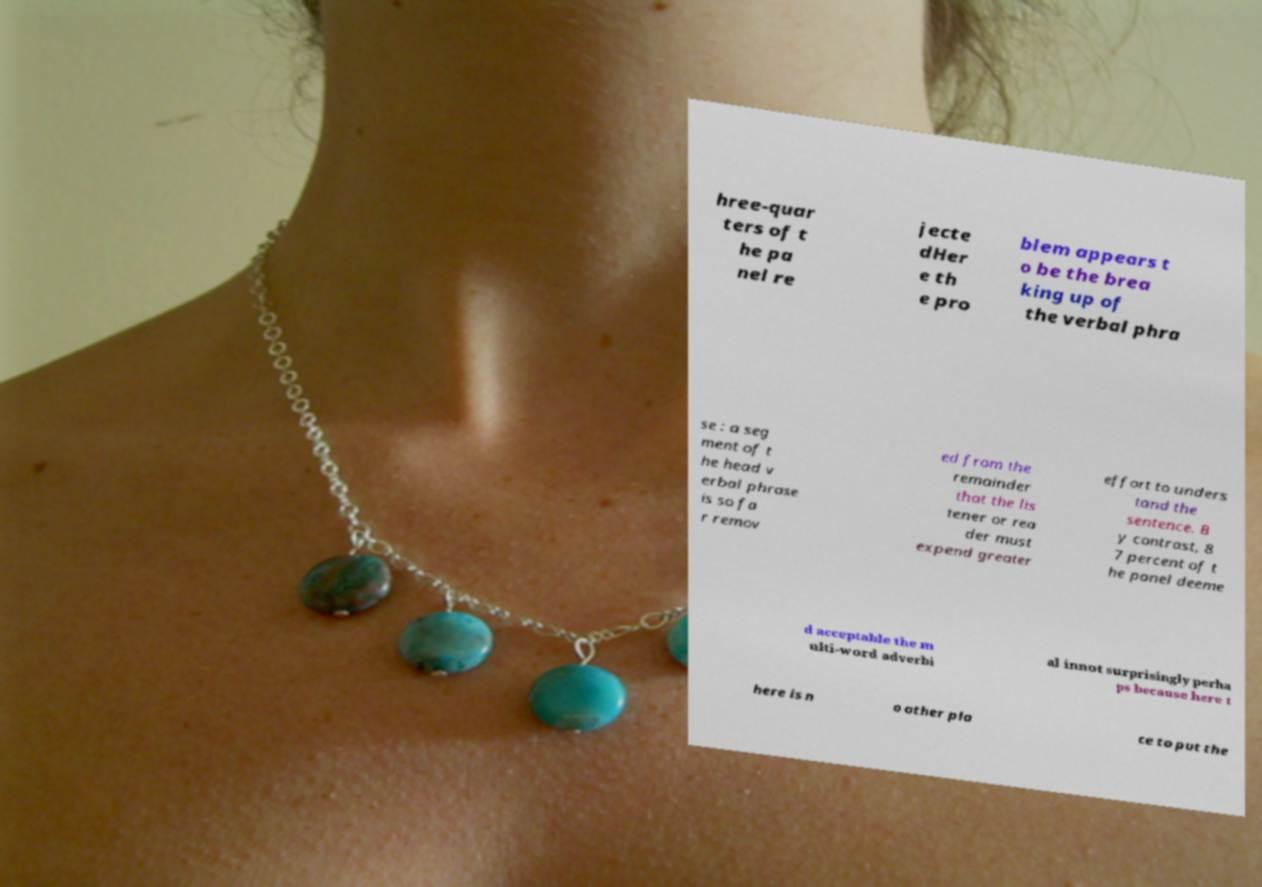I need the written content from this picture converted into text. Can you do that? hree-quar ters of t he pa nel re jecte dHer e th e pro blem appears t o be the brea king up of the verbal phra se : a seg ment of t he head v erbal phrase is so fa r remov ed from the remainder that the lis tener or rea der must expend greater effort to unders tand the sentence. B y contrast, 8 7 percent of t he panel deeme d acceptable the m ulti-word adverbi al innot surprisingly perha ps because here t here is n o other pla ce to put the 